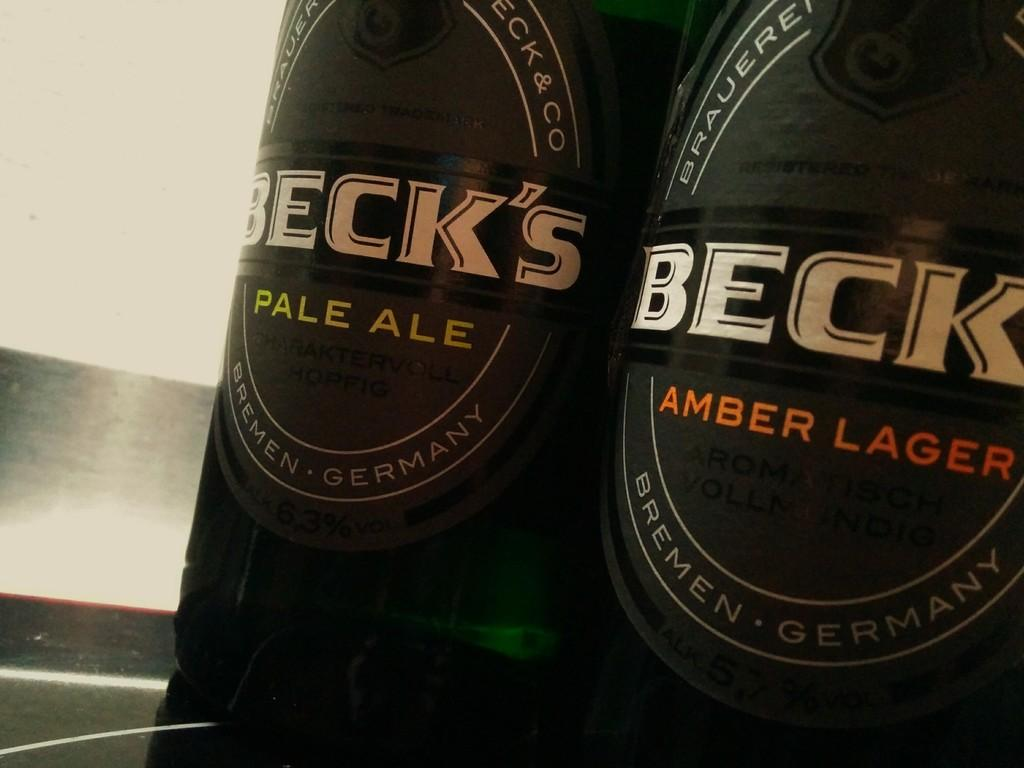<image>
Render a clear and concise summary of the photo. John enjoys two bottles Beck's in the favors of Pale Ale and Amber Lager. 